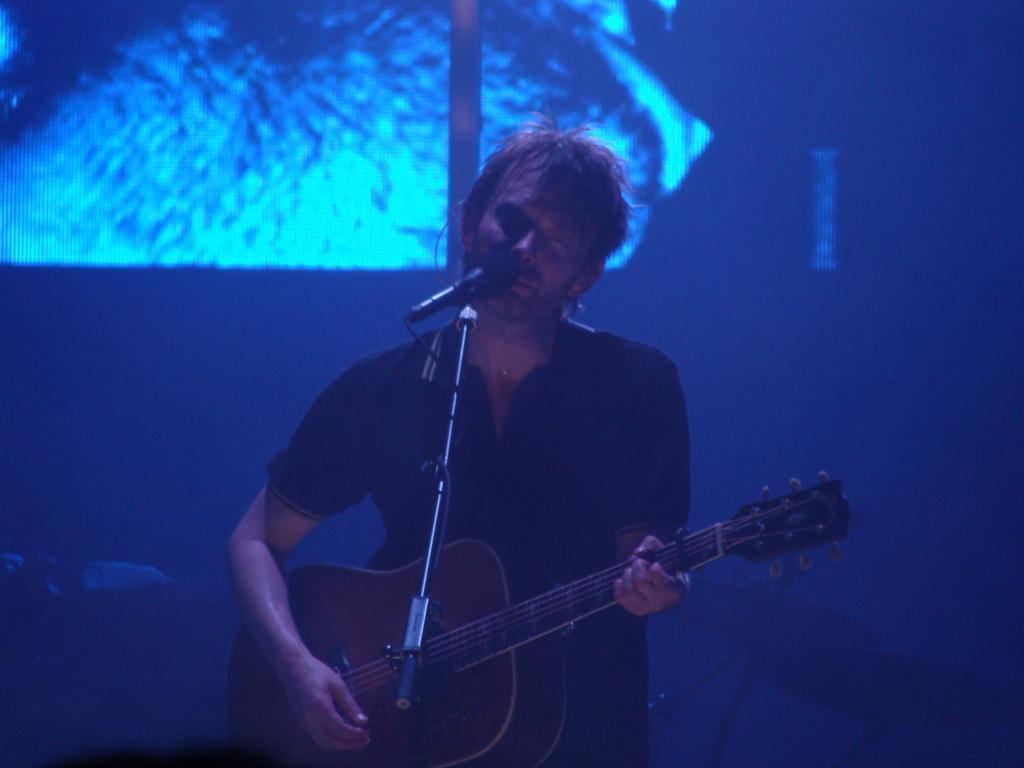In one or two sentences, can you explain what this image depicts? In this image, there is a person playing a guitar behind the mic. This person wearing clothes. 